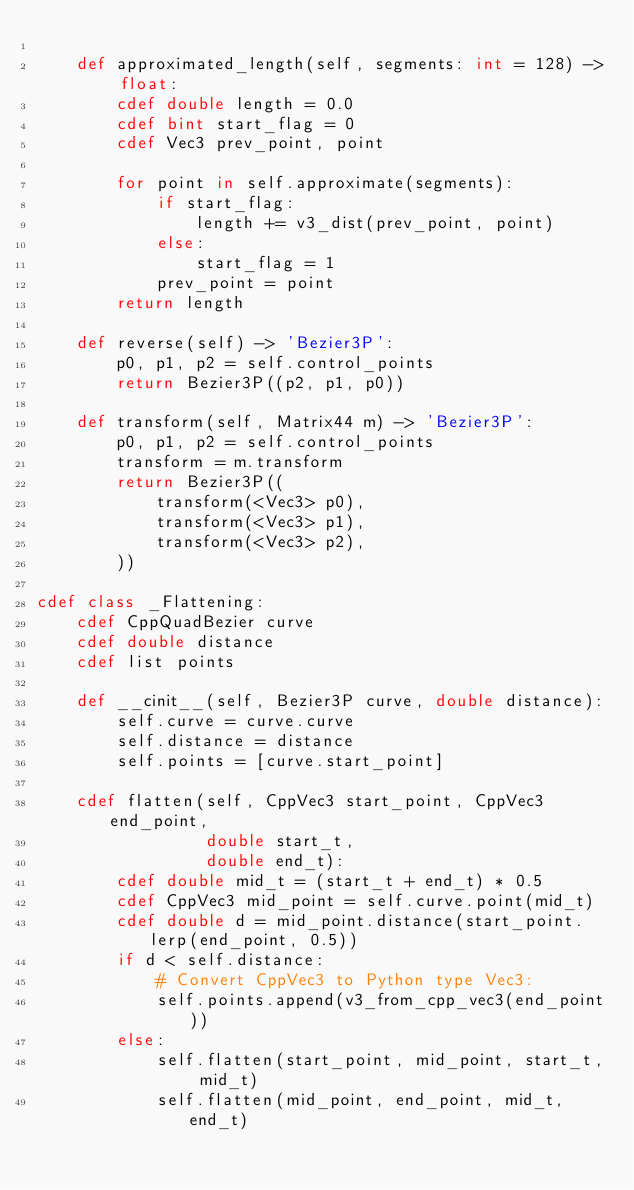<code> <loc_0><loc_0><loc_500><loc_500><_Cython_>
    def approximated_length(self, segments: int = 128) -> float:
        cdef double length = 0.0
        cdef bint start_flag = 0
        cdef Vec3 prev_point, point

        for point in self.approximate(segments):
            if start_flag:
                length += v3_dist(prev_point, point)
            else:
                start_flag = 1
            prev_point = point
        return length

    def reverse(self) -> 'Bezier3P':
        p0, p1, p2 = self.control_points
        return Bezier3P((p2, p1, p0))

    def transform(self, Matrix44 m) -> 'Bezier3P':
        p0, p1, p2 = self.control_points
        transform = m.transform
        return Bezier3P((
            transform(<Vec3> p0),
            transform(<Vec3> p1),
            transform(<Vec3> p2),
        ))

cdef class _Flattening:
    cdef CppQuadBezier curve
    cdef double distance
    cdef list points

    def __cinit__(self, Bezier3P curve, double distance):
        self.curve = curve.curve
        self.distance = distance
        self.points = [curve.start_point]

    cdef flatten(self, CppVec3 start_point, CppVec3 end_point,
                 double start_t,
                 double end_t):
        cdef double mid_t = (start_t + end_t) * 0.5
        cdef CppVec3 mid_point = self.curve.point(mid_t)
        cdef double d = mid_point.distance(start_point.lerp(end_point, 0.5))
        if d < self.distance:
            # Convert CppVec3 to Python type Vec3:
            self.points.append(v3_from_cpp_vec3(end_point))
        else:
            self.flatten(start_point, mid_point, start_t, mid_t)
            self.flatten(mid_point, end_point, mid_t, end_t)</code> 